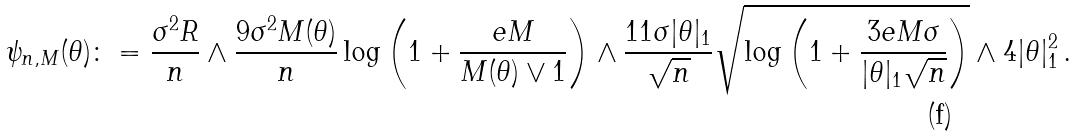Convert formula to latex. <formula><loc_0><loc_0><loc_500><loc_500>\psi _ { n , M } ( \theta ) \colon = \frac { \sigma ^ { 2 } R } { n } \wedge \frac { 9 \sigma ^ { 2 } M ( \theta ) } { n } \log \left ( 1 + \frac { e M } { M ( \theta ) \vee 1 } \right ) \wedge \frac { 1 1 \sigma | \theta | _ { 1 } } { \sqrt { n } } \sqrt { \log \left ( 1 + \frac { 3 e M \sigma } { | \theta | _ { 1 } \sqrt { n } } \right ) } \wedge 4 | \theta | _ { 1 } ^ { 2 } \, .</formula> 